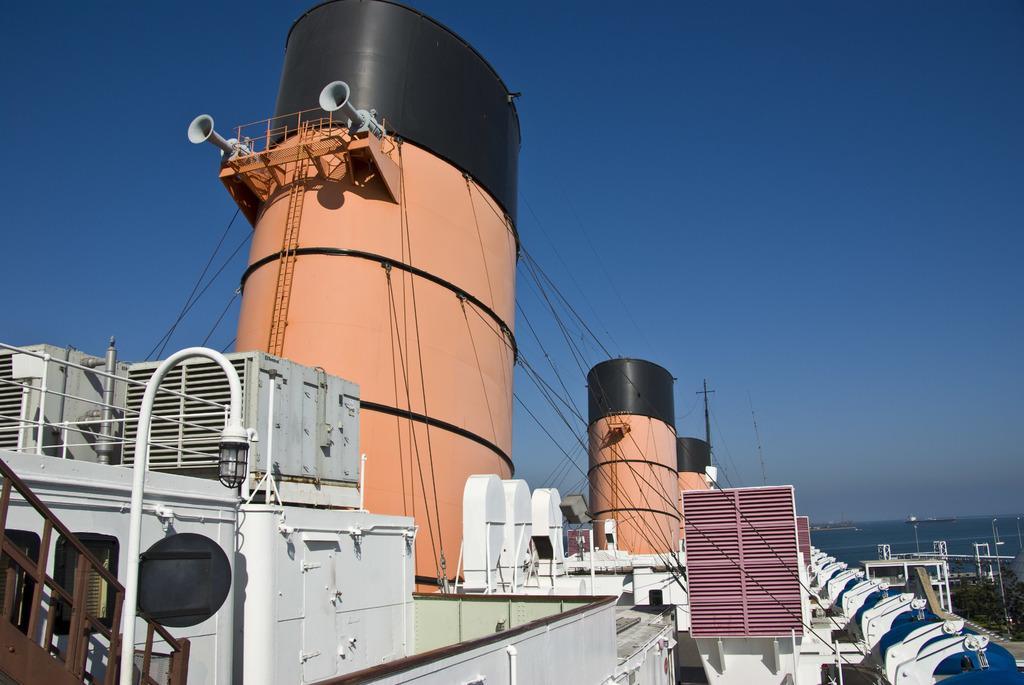How would you summarize this image in a sentence or two? This is a ship and here we can see railings, stairs and a light. In the background, there is water and we can see poles and trees. At the top, there is sky. 